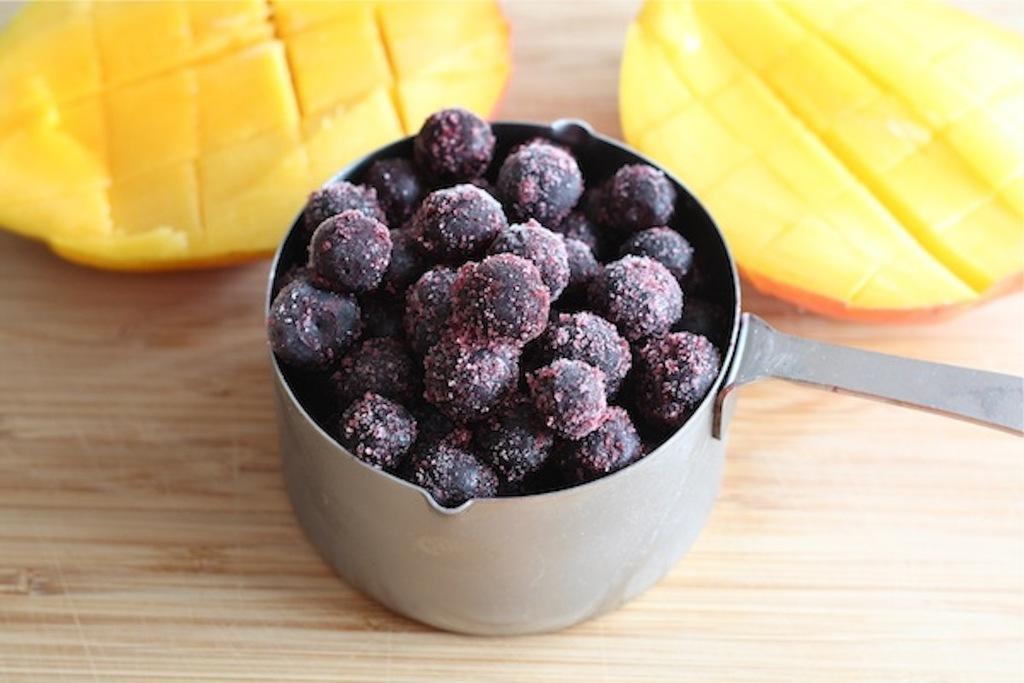Could you give a brief overview of what you see in this image? In this image we can see some food item in the bowl looks like fruits and there are yellow color fruits near the bowl on the table. 